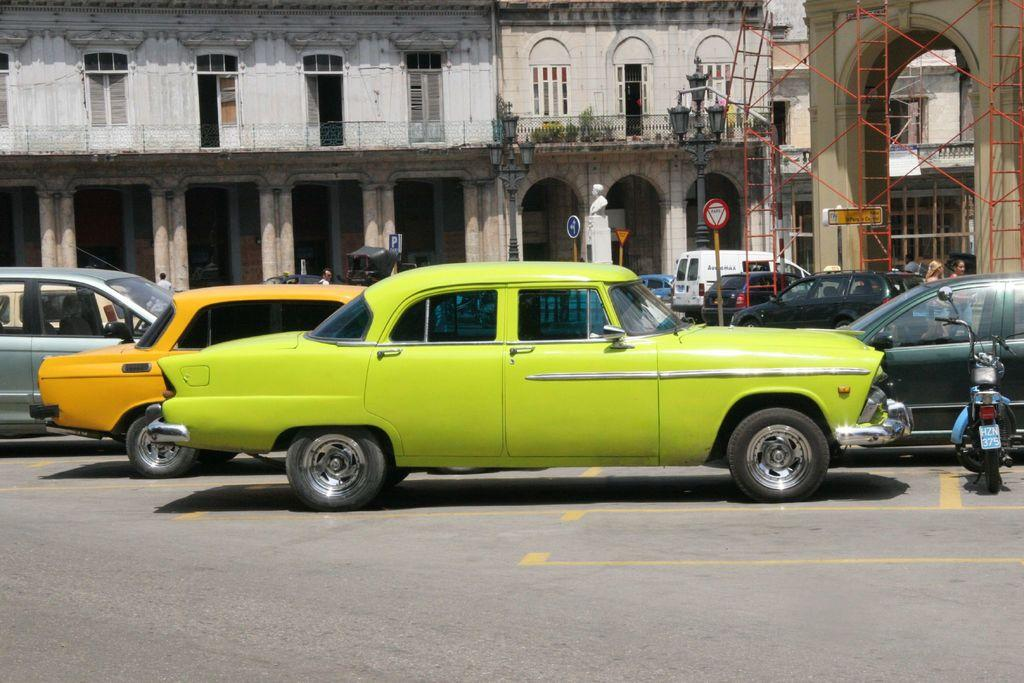<image>
Offer a succinct explanation of the picture presented. A motorcycle with the license plate HZN 375 is parked in front of a lime green car. 